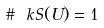<formula> <loc_0><loc_0><loc_500><loc_500>\# \ k S ( U ) = 1</formula> 